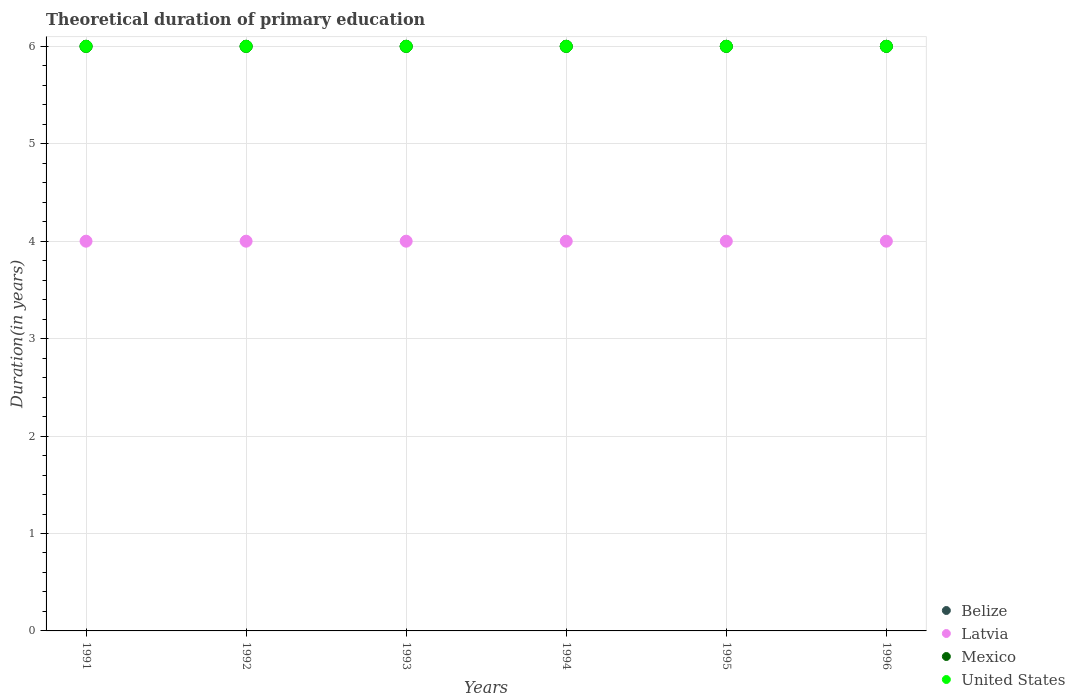How many different coloured dotlines are there?
Your response must be concise. 4. Is the number of dotlines equal to the number of legend labels?
Make the answer very short. Yes. Across all years, what is the minimum total theoretical duration of primary education in Belize?
Your response must be concise. 6. In which year was the total theoretical duration of primary education in Mexico minimum?
Your response must be concise. 1991. What is the total total theoretical duration of primary education in Latvia in the graph?
Your answer should be compact. 24. What is the difference between the total theoretical duration of primary education in United States in 1993 and the total theoretical duration of primary education in Belize in 1992?
Offer a terse response. 0. In the year 1992, what is the difference between the total theoretical duration of primary education in Belize and total theoretical duration of primary education in United States?
Give a very brief answer. 0. In how many years, is the total theoretical duration of primary education in Mexico greater than 2.4 years?
Your answer should be compact. 6. What is the ratio of the total theoretical duration of primary education in Latvia in 1992 to that in 1993?
Give a very brief answer. 1. Is the total theoretical duration of primary education in United States in 1992 less than that in 1995?
Your answer should be compact. No. Is the difference between the total theoretical duration of primary education in Belize in 1992 and 1993 greater than the difference between the total theoretical duration of primary education in United States in 1992 and 1993?
Your answer should be very brief. No. What is the difference between the highest and the second highest total theoretical duration of primary education in United States?
Provide a succinct answer. 0. Does the total theoretical duration of primary education in Belize monotonically increase over the years?
Offer a terse response. No. Is the total theoretical duration of primary education in Belize strictly less than the total theoretical duration of primary education in United States over the years?
Offer a very short reply. No. How many dotlines are there?
Offer a very short reply. 4. Are the values on the major ticks of Y-axis written in scientific E-notation?
Make the answer very short. No. Does the graph contain any zero values?
Provide a short and direct response. No. Where does the legend appear in the graph?
Your answer should be compact. Bottom right. How many legend labels are there?
Ensure brevity in your answer.  4. How are the legend labels stacked?
Your answer should be compact. Vertical. What is the title of the graph?
Provide a short and direct response. Theoretical duration of primary education. What is the label or title of the X-axis?
Ensure brevity in your answer.  Years. What is the label or title of the Y-axis?
Your answer should be very brief. Duration(in years). What is the Duration(in years) in Belize in 1991?
Give a very brief answer. 6. What is the Duration(in years) of Mexico in 1991?
Your response must be concise. 6. What is the Duration(in years) in United States in 1992?
Give a very brief answer. 6. What is the Duration(in years) in Belize in 1993?
Your response must be concise. 6. What is the Duration(in years) of Belize in 1994?
Provide a succinct answer. 6. What is the Duration(in years) of Latvia in 1994?
Provide a short and direct response. 4. What is the Duration(in years) in United States in 1994?
Ensure brevity in your answer.  6. What is the Duration(in years) in Belize in 1995?
Provide a succinct answer. 6. What is the Duration(in years) in Latvia in 1995?
Ensure brevity in your answer.  4. What is the Duration(in years) in Mexico in 1995?
Provide a succinct answer. 6. What is the Duration(in years) in Latvia in 1996?
Your response must be concise. 4. Across all years, what is the maximum Duration(in years) in Latvia?
Your answer should be very brief. 4. Across all years, what is the maximum Duration(in years) in United States?
Offer a very short reply. 6. Across all years, what is the minimum Duration(in years) of Belize?
Your answer should be compact. 6. Across all years, what is the minimum Duration(in years) in Mexico?
Provide a succinct answer. 6. Across all years, what is the minimum Duration(in years) of United States?
Your answer should be compact. 6. What is the total Duration(in years) of Mexico in the graph?
Give a very brief answer. 36. What is the difference between the Duration(in years) in United States in 1991 and that in 1992?
Make the answer very short. 0. What is the difference between the Duration(in years) in Latvia in 1991 and that in 1993?
Give a very brief answer. 0. What is the difference between the Duration(in years) of Mexico in 1991 and that in 1993?
Provide a succinct answer. 0. What is the difference between the Duration(in years) of Latvia in 1991 and that in 1994?
Keep it short and to the point. 0. What is the difference between the Duration(in years) in Mexico in 1991 and that in 1994?
Ensure brevity in your answer.  0. What is the difference between the Duration(in years) in United States in 1991 and that in 1994?
Offer a very short reply. 0. What is the difference between the Duration(in years) in Belize in 1991 and that in 1995?
Ensure brevity in your answer.  0. What is the difference between the Duration(in years) of Latvia in 1991 and that in 1995?
Your answer should be compact. 0. What is the difference between the Duration(in years) in Mexico in 1991 and that in 1995?
Provide a short and direct response. 0. What is the difference between the Duration(in years) in United States in 1991 and that in 1996?
Offer a very short reply. 0. What is the difference between the Duration(in years) of Belize in 1992 and that in 1993?
Provide a short and direct response. 0. What is the difference between the Duration(in years) in United States in 1992 and that in 1993?
Keep it short and to the point. 0. What is the difference between the Duration(in years) in Latvia in 1992 and that in 1994?
Offer a terse response. 0. What is the difference between the Duration(in years) of United States in 1992 and that in 1994?
Make the answer very short. 0. What is the difference between the Duration(in years) of Belize in 1992 and that in 1995?
Provide a succinct answer. 0. What is the difference between the Duration(in years) in Mexico in 1992 and that in 1995?
Keep it short and to the point. 0. What is the difference between the Duration(in years) of Mexico in 1992 and that in 1996?
Keep it short and to the point. 0. What is the difference between the Duration(in years) of Belize in 1993 and that in 1995?
Your answer should be very brief. 0. What is the difference between the Duration(in years) in Latvia in 1993 and that in 1995?
Keep it short and to the point. 0. What is the difference between the Duration(in years) in Latvia in 1993 and that in 1996?
Provide a short and direct response. 0. What is the difference between the Duration(in years) of Mexico in 1993 and that in 1996?
Provide a short and direct response. 0. What is the difference between the Duration(in years) in United States in 1993 and that in 1996?
Provide a succinct answer. 0. What is the difference between the Duration(in years) of Belize in 1994 and that in 1995?
Make the answer very short. 0. What is the difference between the Duration(in years) in Mexico in 1994 and that in 1995?
Offer a terse response. 0. What is the difference between the Duration(in years) of United States in 1994 and that in 1995?
Ensure brevity in your answer.  0. What is the difference between the Duration(in years) of Latvia in 1994 and that in 1996?
Provide a succinct answer. 0. What is the difference between the Duration(in years) in United States in 1994 and that in 1996?
Offer a terse response. 0. What is the difference between the Duration(in years) in Belize in 1995 and that in 1996?
Your response must be concise. 0. What is the difference between the Duration(in years) in Latvia in 1995 and that in 1996?
Offer a very short reply. 0. What is the difference between the Duration(in years) in Belize in 1991 and the Duration(in years) in Latvia in 1992?
Offer a terse response. 2. What is the difference between the Duration(in years) of Belize in 1991 and the Duration(in years) of United States in 1992?
Keep it short and to the point. 0. What is the difference between the Duration(in years) in Latvia in 1991 and the Duration(in years) in Mexico in 1992?
Provide a short and direct response. -2. What is the difference between the Duration(in years) in Latvia in 1991 and the Duration(in years) in United States in 1992?
Your answer should be very brief. -2. What is the difference between the Duration(in years) in Mexico in 1991 and the Duration(in years) in United States in 1992?
Your answer should be compact. 0. What is the difference between the Duration(in years) of Belize in 1991 and the Duration(in years) of Mexico in 1993?
Your answer should be very brief. 0. What is the difference between the Duration(in years) in Latvia in 1991 and the Duration(in years) in Mexico in 1993?
Keep it short and to the point. -2. What is the difference between the Duration(in years) in Mexico in 1991 and the Duration(in years) in United States in 1993?
Your answer should be very brief. 0. What is the difference between the Duration(in years) in Belize in 1991 and the Duration(in years) in United States in 1994?
Keep it short and to the point. 0. What is the difference between the Duration(in years) of Latvia in 1991 and the Duration(in years) of Mexico in 1994?
Give a very brief answer. -2. What is the difference between the Duration(in years) of Latvia in 1991 and the Duration(in years) of United States in 1994?
Ensure brevity in your answer.  -2. What is the difference between the Duration(in years) of Belize in 1991 and the Duration(in years) of Latvia in 1995?
Your answer should be very brief. 2. What is the difference between the Duration(in years) in Latvia in 1991 and the Duration(in years) in Mexico in 1995?
Offer a very short reply. -2. What is the difference between the Duration(in years) in Belize in 1991 and the Duration(in years) in United States in 1996?
Your response must be concise. 0. What is the difference between the Duration(in years) of Mexico in 1991 and the Duration(in years) of United States in 1996?
Provide a short and direct response. 0. What is the difference between the Duration(in years) of Latvia in 1992 and the Duration(in years) of Mexico in 1993?
Provide a succinct answer. -2. What is the difference between the Duration(in years) of Latvia in 1992 and the Duration(in years) of United States in 1993?
Ensure brevity in your answer.  -2. What is the difference between the Duration(in years) of Mexico in 1992 and the Duration(in years) of United States in 1993?
Your answer should be compact. 0. What is the difference between the Duration(in years) of Belize in 1992 and the Duration(in years) of Mexico in 1994?
Ensure brevity in your answer.  0. What is the difference between the Duration(in years) of Belize in 1992 and the Duration(in years) of United States in 1994?
Make the answer very short. 0. What is the difference between the Duration(in years) of Latvia in 1992 and the Duration(in years) of Mexico in 1994?
Keep it short and to the point. -2. What is the difference between the Duration(in years) in Latvia in 1992 and the Duration(in years) in United States in 1994?
Provide a short and direct response. -2. What is the difference between the Duration(in years) in Mexico in 1992 and the Duration(in years) in United States in 1994?
Offer a very short reply. 0. What is the difference between the Duration(in years) in Belize in 1992 and the Duration(in years) in Latvia in 1995?
Provide a short and direct response. 2. What is the difference between the Duration(in years) of Latvia in 1992 and the Duration(in years) of Mexico in 1995?
Make the answer very short. -2. What is the difference between the Duration(in years) of Latvia in 1992 and the Duration(in years) of United States in 1995?
Your answer should be very brief. -2. What is the difference between the Duration(in years) in Mexico in 1992 and the Duration(in years) in United States in 1995?
Give a very brief answer. 0. What is the difference between the Duration(in years) in Belize in 1992 and the Duration(in years) in Latvia in 1996?
Provide a short and direct response. 2. What is the difference between the Duration(in years) in Latvia in 1992 and the Duration(in years) in United States in 1996?
Provide a succinct answer. -2. What is the difference between the Duration(in years) of Mexico in 1992 and the Duration(in years) of United States in 1996?
Your response must be concise. 0. What is the difference between the Duration(in years) in Belize in 1993 and the Duration(in years) in United States in 1994?
Ensure brevity in your answer.  0. What is the difference between the Duration(in years) of Mexico in 1993 and the Duration(in years) of United States in 1994?
Your answer should be compact. 0. What is the difference between the Duration(in years) in Latvia in 1993 and the Duration(in years) in United States in 1995?
Make the answer very short. -2. What is the difference between the Duration(in years) in Belize in 1993 and the Duration(in years) in Latvia in 1996?
Provide a short and direct response. 2. What is the difference between the Duration(in years) of Belize in 1993 and the Duration(in years) of Mexico in 1996?
Offer a very short reply. 0. What is the difference between the Duration(in years) in Mexico in 1993 and the Duration(in years) in United States in 1996?
Make the answer very short. 0. What is the difference between the Duration(in years) of Belize in 1994 and the Duration(in years) of Mexico in 1995?
Provide a short and direct response. 0. What is the difference between the Duration(in years) of Belize in 1994 and the Duration(in years) of Latvia in 1996?
Your answer should be compact. 2. What is the difference between the Duration(in years) in Belize in 1994 and the Duration(in years) in United States in 1996?
Give a very brief answer. 0. What is the difference between the Duration(in years) of Belize in 1995 and the Duration(in years) of United States in 1996?
Your answer should be very brief. 0. What is the difference between the Duration(in years) in Latvia in 1995 and the Duration(in years) in Mexico in 1996?
Provide a succinct answer. -2. What is the difference between the Duration(in years) in Mexico in 1995 and the Duration(in years) in United States in 1996?
Provide a succinct answer. 0. What is the average Duration(in years) in Latvia per year?
Provide a succinct answer. 4. What is the average Duration(in years) of United States per year?
Provide a succinct answer. 6. In the year 1991, what is the difference between the Duration(in years) in Belize and Duration(in years) in Latvia?
Make the answer very short. 2. In the year 1991, what is the difference between the Duration(in years) in Latvia and Duration(in years) in Mexico?
Ensure brevity in your answer.  -2. In the year 1991, what is the difference between the Duration(in years) of Latvia and Duration(in years) of United States?
Give a very brief answer. -2. In the year 1991, what is the difference between the Duration(in years) of Mexico and Duration(in years) of United States?
Keep it short and to the point. 0. In the year 1992, what is the difference between the Duration(in years) of Belize and Duration(in years) of Latvia?
Give a very brief answer. 2. In the year 1992, what is the difference between the Duration(in years) of Latvia and Duration(in years) of United States?
Provide a short and direct response. -2. In the year 1993, what is the difference between the Duration(in years) in Belize and Duration(in years) in Mexico?
Offer a very short reply. 0. In the year 1993, what is the difference between the Duration(in years) of Latvia and Duration(in years) of Mexico?
Provide a short and direct response. -2. In the year 1993, what is the difference between the Duration(in years) in Latvia and Duration(in years) in United States?
Make the answer very short. -2. In the year 1994, what is the difference between the Duration(in years) of Belize and Duration(in years) of Latvia?
Your answer should be compact. 2. In the year 1994, what is the difference between the Duration(in years) of Latvia and Duration(in years) of United States?
Your response must be concise. -2. In the year 1994, what is the difference between the Duration(in years) in Mexico and Duration(in years) in United States?
Your answer should be compact. 0. In the year 1995, what is the difference between the Duration(in years) in Belize and Duration(in years) in Latvia?
Your answer should be compact. 2. In the year 1995, what is the difference between the Duration(in years) of Belize and Duration(in years) of Mexico?
Your answer should be very brief. 0. In the year 1995, what is the difference between the Duration(in years) of Latvia and Duration(in years) of Mexico?
Your answer should be compact. -2. In the year 1995, what is the difference between the Duration(in years) in Latvia and Duration(in years) in United States?
Give a very brief answer. -2. In the year 1996, what is the difference between the Duration(in years) in Belize and Duration(in years) in Mexico?
Your response must be concise. 0. In the year 1996, what is the difference between the Duration(in years) of Belize and Duration(in years) of United States?
Your response must be concise. 0. In the year 1996, what is the difference between the Duration(in years) of Latvia and Duration(in years) of Mexico?
Your response must be concise. -2. In the year 1996, what is the difference between the Duration(in years) in Latvia and Duration(in years) in United States?
Provide a short and direct response. -2. What is the ratio of the Duration(in years) of Latvia in 1991 to that in 1994?
Provide a succinct answer. 1. What is the ratio of the Duration(in years) in Mexico in 1991 to that in 1994?
Offer a very short reply. 1. What is the ratio of the Duration(in years) of United States in 1991 to that in 1994?
Your answer should be compact. 1. What is the ratio of the Duration(in years) of Belize in 1991 to that in 1995?
Ensure brevity in your answer.  1. What is the ratio of the Duration(in years) of Mexico in 1991 to that in 1995?
Your answer should be compact. 1. What is the ratio of the Duration(in years) in United States in 1991 to that in 1995?
Keep it short and to the point. 1. What is the ratio of the Duration(in years) in Belize in 1991 to that in 1996?
Provide a short and direct response. 1. What is the ratio of the Duration(in years) in Mexico in 1991 to that in 1996?
Give a very brief answer. 1. What is the ratio of the Duration(in years) in United States in 1991 to that in 1996?
Ensure brevity in your answer.  1. What is the ratio of the Duration(in years) of Latvia in 1992 to that in 1993?
Provide a succinct answer. 1. What is the ratio of the Duration(in years) of Mexico in 1992 to that in 1993?
Make the answer very short. 1. What is the ratio of the Duration(in years) in United States in 1992 to that in 1993?
Make the answer very short. 1. What is the ratio of the Duration(in years) of United States in 1992 to that in 1994?
Provide a succinct answer. 1. What is the ratio of the Duration(in years) in Belize in 1992 to that in 1995?
Provide a succinct answer. 1. What is the ratio of the Duration(in years) in Latvia in 1992 to that in 1995?
Offer a very short reply. 1. What is the ratio of the Duration(in years) of Mexico in 1992 to that in 1995?
Offer a very short reply. 1. What is the ratio of the Duration(in years) in United States in 1992 to that in 1995?
Provide a short and direct response. 1. What is the ratio of the Duration(in years) in Belize in 1992 to that in 1996?
Offer a terse response. 1. What is the ratio of the Duration(in years) in United States in 1992 to that in 1996?
Make the answer very short. 1. What is the ratio of the Duration(in years) in Belize in 1993 to that in 1994?
Provide a short and direct response. 1. What is the ratio of the Duration(in years) in Latvia in 1993 to that in 1994?
Your answer should be compact. 1. What is the ratio of the Duration(in years) in United States in 1993 to that in 1994?
Offer a terse response. 1. What is the ratio of the Duration(in years) in Latvia in 1993 to that in 1995?
Provide a short and direct response. 1. What is the ratio of the Duration(in years) of Mexico in 1993 to that in 1995?
Offer a terse response. 1. What is the ratio of the Duration(in years) of Belize in 1993 to that in 1996?
Your answer should be very brief. 1. What is the ratio of the Duration(in years) of United States in 1994 to that in 1995?
Provide a short and direct response. 1. What is the ratio of the Duration(in years) of Belize in 1994 to that in 1996?
Make the answer very short. 1. What is the ratio of the Duration(in years) in Mexico in 1994 to that in 1996?
Offer a very short reply. 1. What is the ratio of the Duration(in years) in United States in 1994 to that in 1996?
Your response must be concise. 1. What is the ratio of the Duration(in years) in United States in 1995 to that in 1996?
Your answer should be very brief. 1. What is the difference between the highest and the second highest Duration(in years) of Latvia?
Provide a short and direct response. 0. What is the difference between the highest and the lowest Duration(in years) of Mexico?
Offer a terse response. 0. 